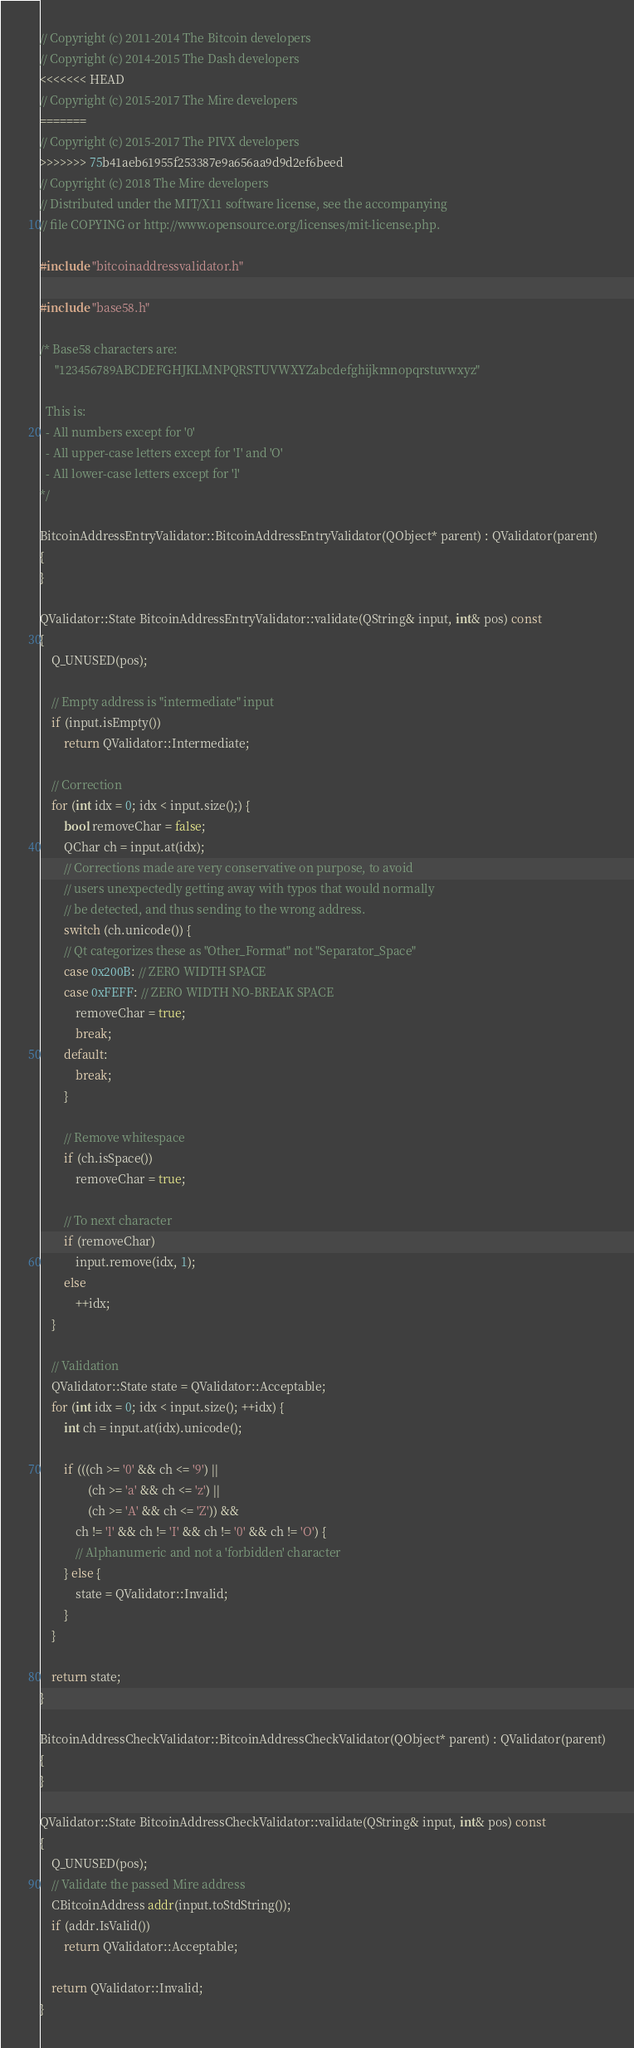Convert code to text. <code><loc_0><loc_0><loc_500><loc_500><_C++_>// Copyright (c) 2011-2014 The Bitcoin developers
// Copyright (c) 2014-2015 The Dash developers
<<<<<<< HEAD
// Copyright (c) 2015-2017 The Mire developers
=======
// Copyright (c) 2015-2017 The PIVX developers
>>>>>>> 75b41aeb61955f253387e9a656aa9d9d2ef6beed
// Copyright (c) 2018 The Mire developers
// Distributed under the MIT/X11 software license, see the accompanying
// file COPYING or http://www.opensource.org/licenses/mit-license.php.

#include "bitcoinaddressvalidator.h"

#include "base58.h"

/* Base58 characters are:
     "123456789ABCDEFGHJKLMNPQRSTUVWXYZabcdefghijkmnopqrstuvwxyz"

  This is:
  - All numbers except for '0'
  - All upper-case letters except for 'I' and 'O'
  - All lower-case letters except for 'l'
*/

BitcoinAddressEntryValidator::BitcoinAddressEntryValidator(QObject* parent) : QValidator(parent)
{
}

QValidator::State BitcoinAddressEntryValidator::validate(QString& input, int& pos) const
{
    Q_UNUSED(pos);

    // Empty address is "intermediate" input
    if (input.isEmpty())
        return QValidator::Intermediate;

    // Correction
    for (int idx = 0; idx < input.size();) {
        bool removeChar = false;
        QChar ch = input.at(idx);
        // Corrections made are very conservative on purpose, to avoid
        // users unexpectedly getting away with typos that would normally
        // be detected, and thus sending to the wrong address.
        switch (ch.unicode()) {
        // Qt categorizes these as "Other_Format" not "Separator_Space"
        case 0x200B: // ZERO WIDTH SPACE
        case 0xFEFF: // ZERO WIDTH NO-BREAK SPACE
            removeChar = true;
            break;
        default:
            break;
        }

        // Remove whitespace
        if (ch.isSpace())
            removeChar = true;

        // To next character
        if (removeChar)
            input.remove(idx, 1);
        else
            ++idx;
    }

    // Validation
    QValidator::State state = QValidator::Acceptable;
    for (int idx = 0; idx < input.size(); ++idx) {
        int ch = input.at(idx).unicode();

        if (((ch >= '0' && ch <= '9') ||
                (ch >= 'a' && ch <= 'z') ||
                (ch >= 'A' && ch <= 'Z')) &&
            ch != 'l' && ch != 'I' && ch != '0' && ch != 'O') {
            // Alphanumeric and not a 'forbidden' character
        } else {
            state = QValidator::Invalid;
        }
    }

    return state;
}

BitcoinAddressCheckValidator::BitcoinAddressCheckValidator(QObject* parent) : QValidator(parent)
{
}

QValidator::State BitcoinAddressCheckValidator::validate(QString& input, int& pos) const
{
    Q_UNUSED(pos);
    // Validate the passed Mire address
    CBitcoinAddress addr(input.toStdString());
    if (addr.IsValid())
        return QValidator::Acceptable;

    return QValidator::Invalid;
}
</code> 